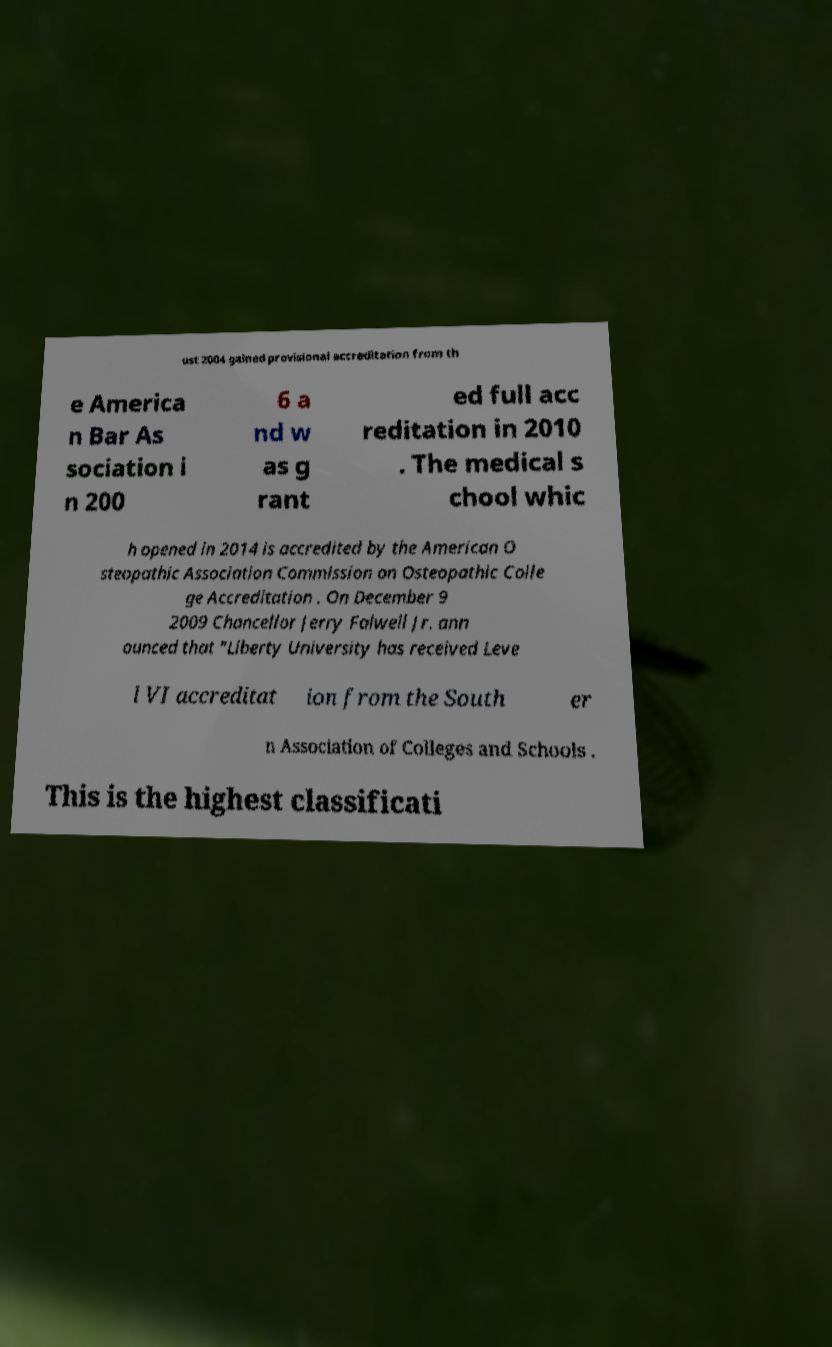Please read and relay the text visible in this image. What does it say? ust 2004 gained provisional accreditation from th e America n Bar As sociation i n 200 6 a nd w as g rant ed full acc reditation in 2010 . The medical s chool whic h opened in 2014 is accredited by the American O steopathic Association Commission on Osteopathic Colle ge Accreditation . On December 9 2009 Chancellor Jerry Falwell Jr. ann ounced that "Liberty University has received Leve l VI accreditat ion from the South er n Association of Colleges and Schools . This is the highest classificati 